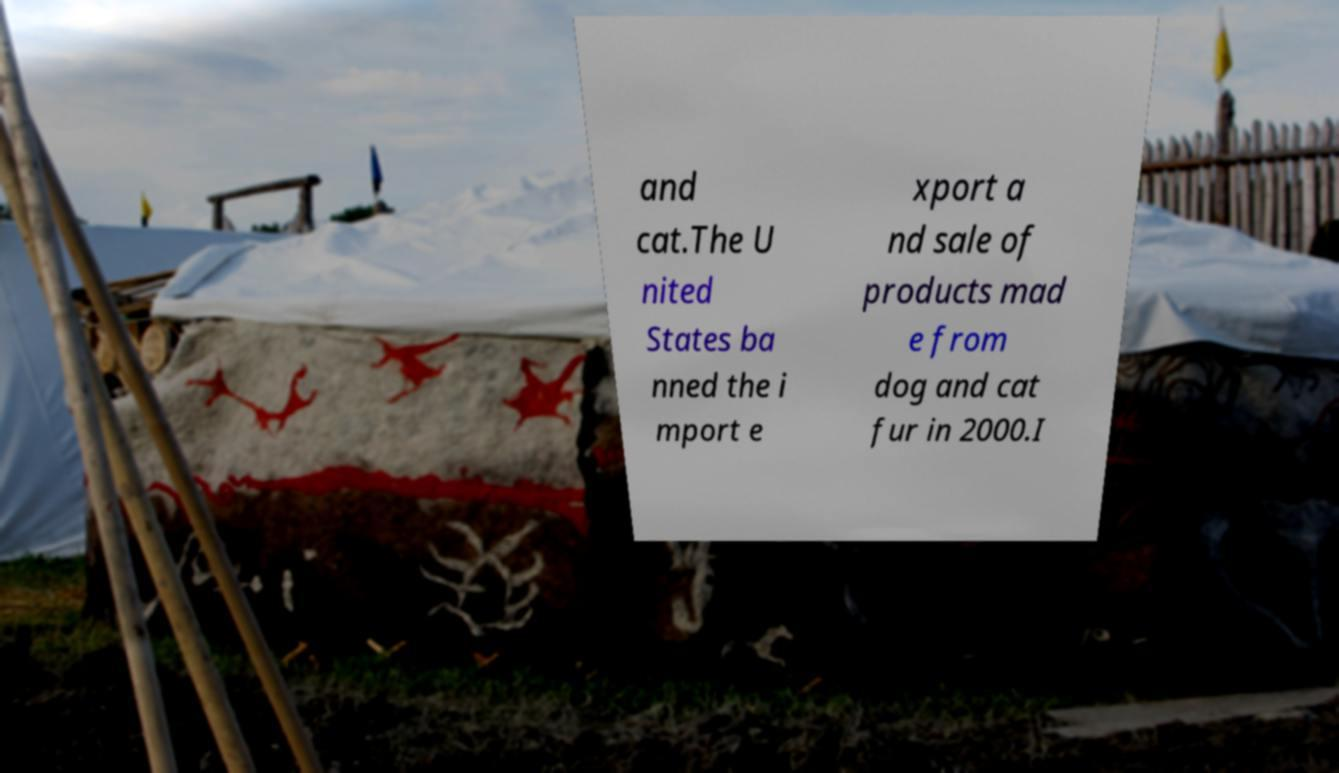Can you accurately transcribe the text from the provided image for me? and cat.The U nited States ba nned the i mport e xport a nd sale of products mad e from dog and cat fur in 2000.I 